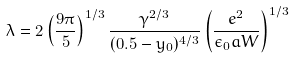<formula> <loc_0><loc_0><loc_500><loc_500>\lambda = 2 \left ( \frac { 9 \pi } 5 \right ) ^ { 1 / 3 } \frac { \gamma ^ { 2 / 3 } } { ( 0 . 5 - y _ { 0 } ) ^ { 4 / 3 } } \left ( \frac { e ^ { 2 } } { \epsilon _ { 0 } a W } \right ) ^ { 1 / 3 }</formula> 